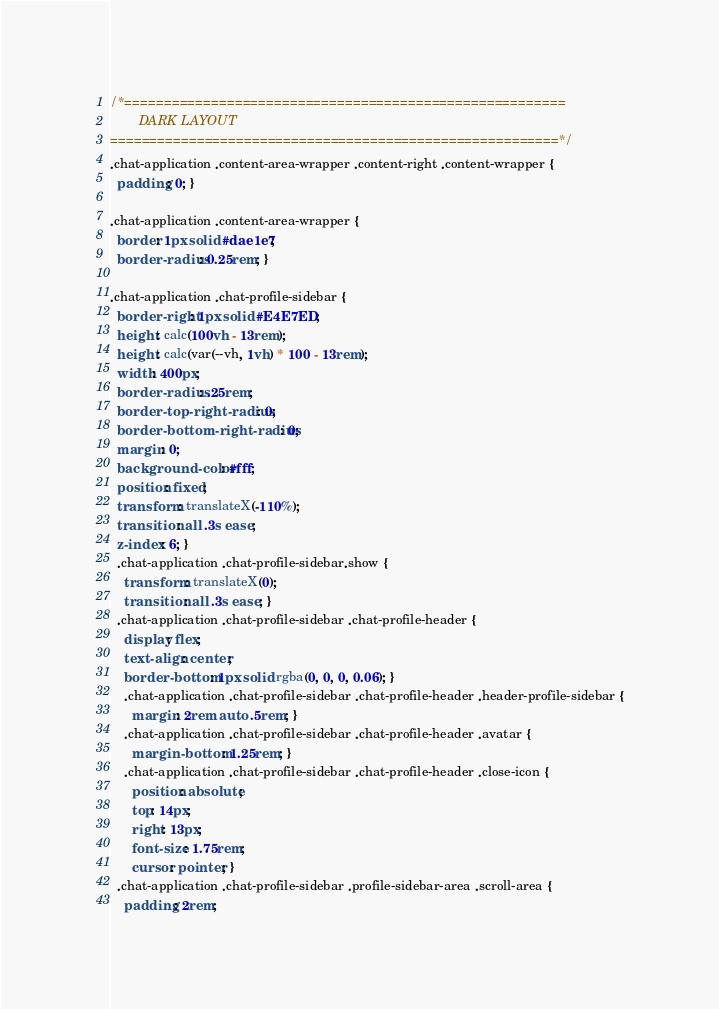Convert code to text. <code><loc_0><loc_0><loc_500><loc_500><_CSS_>/*========================================================
        DARK LAYOUT
=========================================================*/
.chat-application .content-area-wrapper .content-right .content-wrapper {
  padding: 0; }

.chat-application .content-area-wrapper {
  border: 1px solid #dae1e7;
  border-radius: 0.25rem; }

.chat-application .chat-profile-sidebar {
  border-right: 1px solid #E4E7ED;
  height: calc(100vh - 13rem);
  height: calc(var(--vh, 1vh) * 100 - 13rem);
  width: 400px;
  border-radius: .25rem;
  border-top-right-radius: 0;
  border-bottom-right-radius: 0;
  margin: 0;
  background-color: #fff;
  position: fixed;
  transform: translateX(-110%);
  transition: all .3s ease;
  z-index: 6; }
  .chat-application .chat-profile-sidebar.show {
    transform: translateX(0);
    transition: all .3s ease; }
  .chat-application .chat-profile-sidebar .chat-profile-header {
    display: flex;
    text-align: center;
    border-bottom: 1px solid rgba(0, 0, 0, 0.06); }
    .chat-application .chat-profile-sidebar .chat-profile-header .header-profile-sidebar {
      margin: 2rem auto .5rem; }
    .chat-application .chat-profile-sidebar .chat-profile-header .avatar {
      margin-bottom: 1.25rem; }
    .chat-application .chat-profile-sidebar .chat-profile-header .close-icon {
      position: absolute;
      top: 14px;
      right: 13px;
      font-size: 1.75rem;
      cursor: pointer; }
  .chat-application .chat-profile-sidebar .profile-sidebar-area .scroll-area {
    padding: 2rem;</code> 